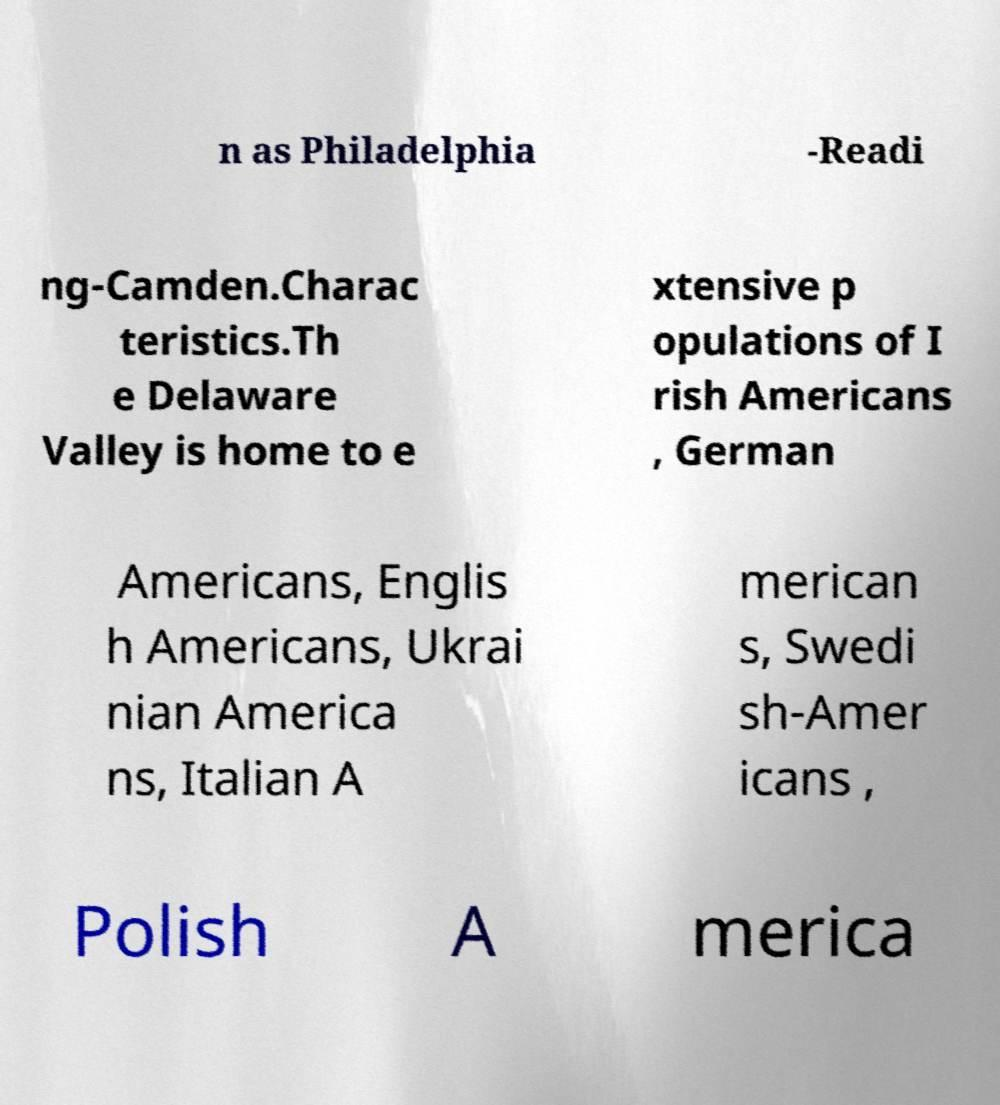Can you accurately transcribe the text from the provided image for me? n as Philadelphia -Readi ng-Camden.Charac teristics.Th e Delaware Valley is home to e xtensive p opulations of I rish Americans , German Americans, Englis h Americans, Ukrai nian America ns, Italian A merican s, Swedi sh-Amer icans , Polish A merica 